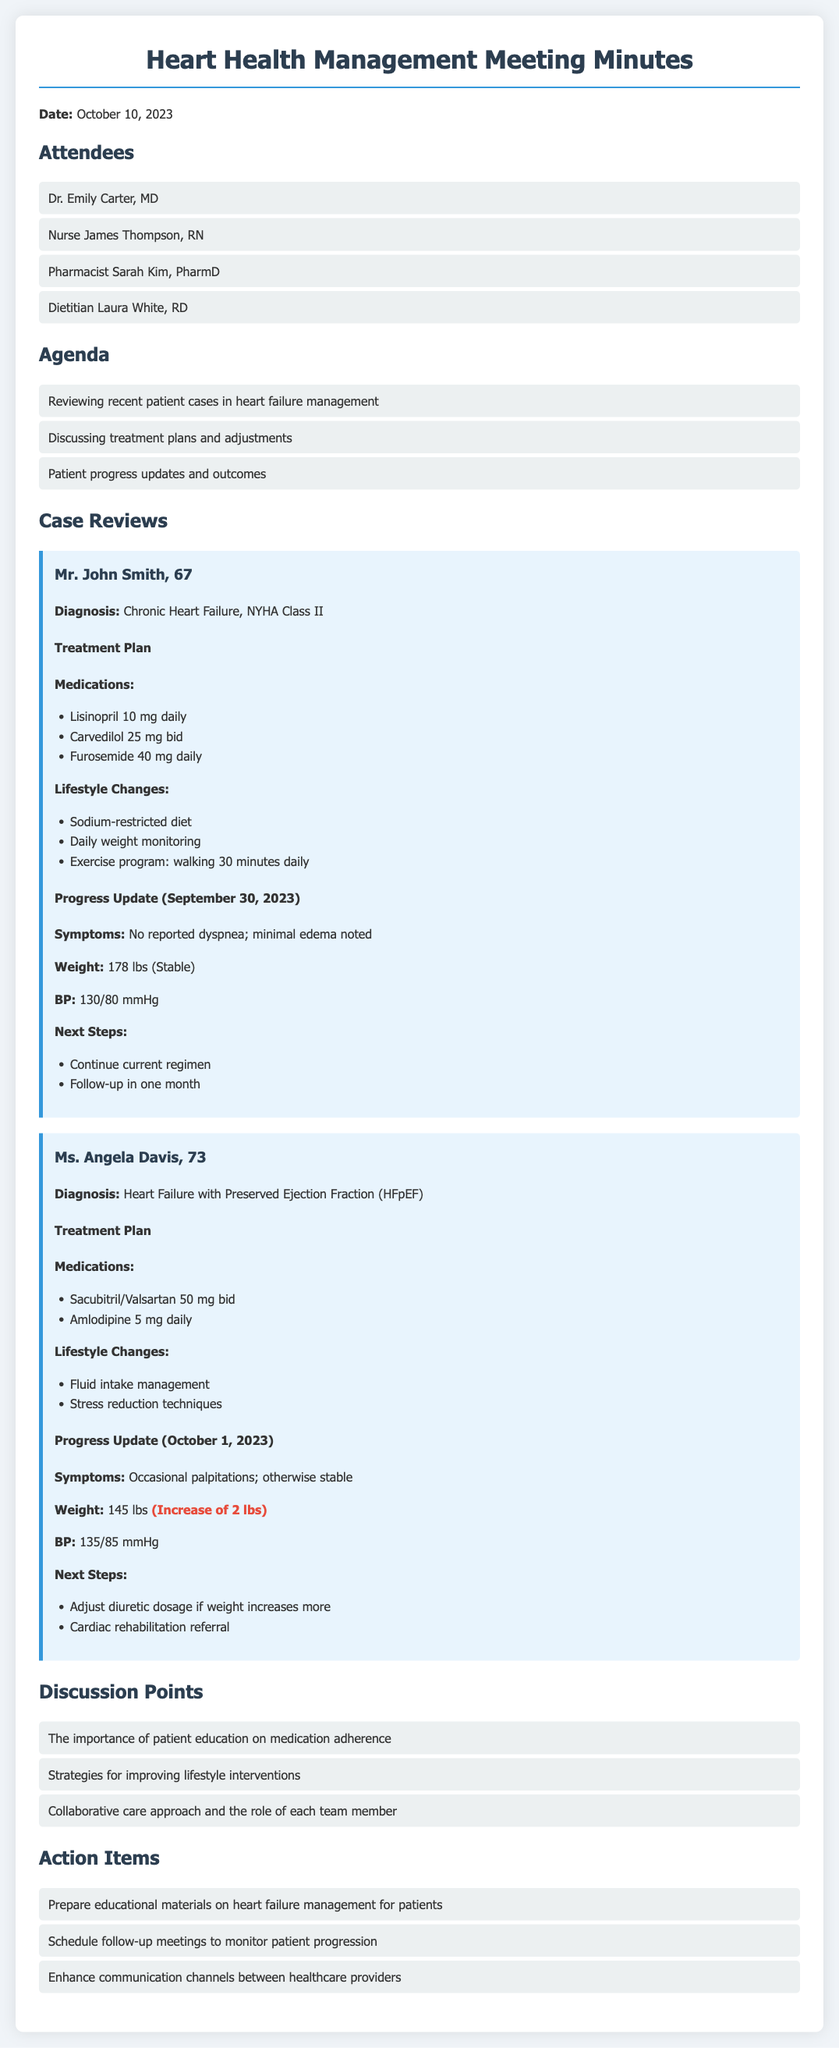What is the date of the meeting? The date is stated at the beginning of the document.
Answer: October 10, 2023 Who is the pharmacist in attendance? The attendees section lists all participants and their roles.
Answer: Pharmacist Sarah Kim, PharmD What is Mr. John Smith's diagnosis? The diagnosis for Mr. John Smith is included in his case review.
Answer: Chronic Heart Failure, NYHA Class II What medication is Ms. Angela Davis taking daily? The treatment plan includes the medications prescribed to Ms. Angela Davis.
Answer: Amlodipine 5 mg daily What was Mr. John Smith's blood pressure reading? The progress update for Mr. John Smith includes his blood pressure measurement.
Answer: 130/80 mmHg What lifestyle change is suggested for both patients? The treatment plans for both patients outline recommended lifestyle changes.
Answer: Sodium-restricted diet What is the next step for Ms. Angela Davis? The "Next Steps" section for Ms. Angela Davis provides the recommended actions.
Answer: Adjust diuretic dosage if weight increases more What strategy was discussed concerning patient education? The discussion points include specific strategies mentioned in the meeting.
Answer: Importance of patient education on medication adherence 